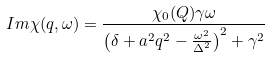<formula> <loc_0><loc_0><loc_500><loc_500>I m \chi ( q , \omega ) = \frac { \chi _ { 0 } ( Q ) \gamma \omega } { \left ( \delta + a ^ { 2 } q ^ { 2 } - \frac { \omega ^ { 2 } } { \Delta ^ { 2 } } \right ) ^ { 2 } + \gamma ^ { 2 } }</formula> 